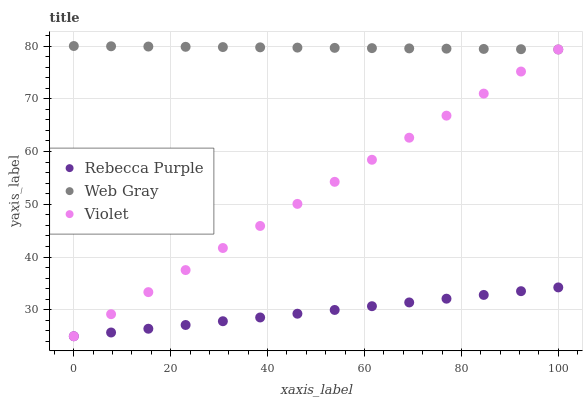Does Rebecca Purple have the minimum area under the curve?
Answer yes or no. Yes. Does Web Gray have the maximum area under the curve?
Answer yes or no. Yes. Does Violet have the minimum area under the curve?
Answer yes or no. No. Does Violet have the maximum area under the curve?
Answer yes or no. No. Is Rebecca Purple the smoothest?
Answer yes or no. Yes. Is Web Gray the roughest?
Answer yes or no. Yes. Is Violet the smoothest?
Answer yes or no. No. Is Violet the roughest?
Answer yes or no. No. Does Rebecca Purple have the lowest value?
Answer yes or no. Yes. Does Web Gray have the highest value?
Answer yes or no. Yes. Does Violet have the highest value?
Answer yes or no. No. Is Violet less than Web Gray?
Answer yes or no. Yes. Is Web Gray greater than Rebecca Purple?
Answer yes or no. Yes. Does Rebecca Purple intersect Violet?
Answer yes or no. Yes. Is Rebecca Purple less than Violet?
Answer yes or no. No. Is Rebecca Purple greater than Violet?
Answer yes or no. No. Does Violet intersect Web Gray?
Answer yes or no. No. 